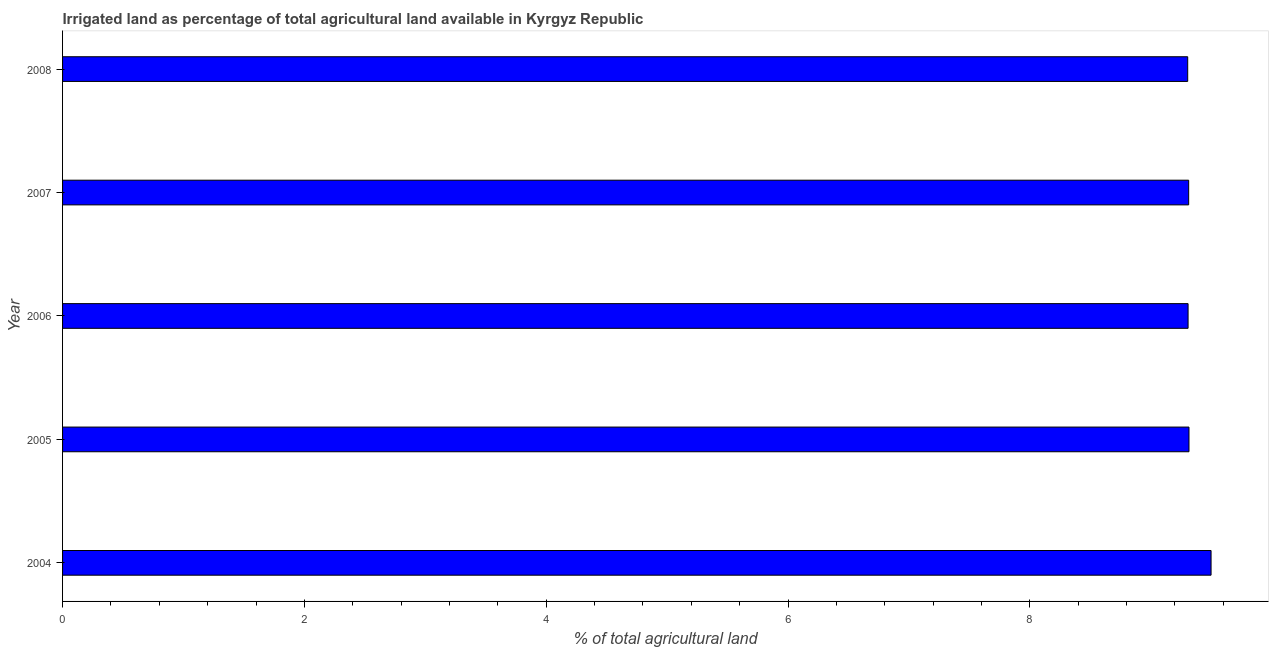Does the graph contain any zero values?
Your response must be concise. No. What is the title of the graph?
Ensure brevity in your answer.  Irrigated land as percentage of total agricultural land available in Kyrgyz Republic. What is the label or title of the X-axis?
Give a very brief answer. % of total agricultural land. What is the label or title of the Y-axis?
Offer a terse response. Year. What is the percentage of agricultural irrigated land in 2006?
Offer a terse response. 9.31. Across all years, what is the maximum percentage of agricultural irrigated land?
Offer a very short reply. 9.5. Across all years, what is the minimum percentage of agricultural irrigated land?
Provide a succinct answer. 9.31. In which year was the percentage of agricultural irrigated land maximum?
Your answer should be very brief. 2004. In which year was the percentage of agricultural irrigated land minimum?
Keep it short and to the point. 2008. What is the sum of the percentage of agricultural irrigated land?
Provide a short and direct response. 46.74. What is the difference between the percentage of agricultural irrigated land in 2005 and 2008?
Your answer should be very brief. 0.01. What is the average percentage of agricultural irrigated land per year?
Make the answer very short. 9.35. What is the median percentage of agricultural irrigated land?
Ensure brevity in your answer.  9.31. In how many years, is the percentage of agricultural irrigated land greater than 7.2 %?
Your answer should be compact. 5. Do a majority of the years between 2008 and 2006 (inclusive) have percentage of agricultural irrigated land greater than 4.8 %?
Your answer should be very brief. Yes. What is the ratio of the percentage of agricultural irrigated land in 2005 to that in 2007?
Make the answer very short. 1. Is the percentage of agricultural irrigated land in 2005 less than that in 2006?
Offer a very short reply. No. Is the difference between the percentage of agricultural irrigated land in 2005 and 2006 greater than the difference between any two years?
Your answer should be very brief. No. What is the difference between the highest and the second highest percentage of agricultural irrigated land?
Your answer should be very brief. 0.18. What is the difference between the highest and the lowest percentage of agricultural irrigated land?
Make the answer very short. 0.19. In how many years, is the percentage of agricultural irrigated land greater than the average percentage of agricultural irrigated land taken over all years?
Offer a very short reply. 1. Are all the bars in the graph horizontal?
Offer a terse response. Yes. What is the difference between two consecutive major ticks on the X-axis?
Keep it short and to the point. 2. Are the values on the major ticks of X-axis written in scientific E-notation?
Provide a short and direct response. No. What is the % of total agricultural land of 2004?
Your answer should be compact. 9.5. What is the % of total agricultural land of 2005?
Your answer should be compact. 9.32. What is the % of total agricultural land of 2006?
Give a very brief answer. 9.31. What is the % of total agricultural land of 2007?
Your answer should be compact. 9.31. What is the % of total agricultural land of 2008?
Your answer should be compact. 9.31. What is the difference between the % of total agricultural land in 2004 and 2005?
Provide a succinct answer. 0.18. What is the difference between the % of total agricultural land in 2004 and 2006?
Ensure brevity in your answer.  0.19. What is the difference between the % of total agricultural land in 2004 and 2007?
Provide a succinct answer. 0.19. What is the difference between the % of total agricultural land in 2004 and 2008?
Your response must be concise. 0.19. What is the difference between the % of total agricultural land in 2005 and 2006?
Your response must be concise. 0.01. What is the difference between the % of total agricultural land in 2005 and 2007?
Provide a succinct answer. 0. What is the difference between the % of total agricultural land in 2005 and 2008?
Keep it short and to the point. 0.01. What is the difference between the % of total agricultural land in 2006 and 2007?
Keep it short and to the point. -0. What is the difference between the % of total agricultural land in 2006 and 2008?
Provide a short and direct response. 0. What is the difference between the % of total agricultural land in 2007 and 2008?
Your response must be concise. 0.01. What is the ratio of the % of total agricultural land in 2004 to that in 2005?
Offer a terse response. 1.02. What is the ratio of the % of total agricultural land in 2004 to that in 2006?
Offer a very short reply. 1.02. What is the ratio of the % of total agricultural land in 2004 to that in 2007?
Provide a succinct answer. 1.02. What is the ratio of the % of total agricultural land in 2004 to that in 2008?
Your answer should be compact. 1.02. What is the ratio of the % of total agricultural land in 2006 to that in 2007?
Your answer should be compact. 1. What is the ratio of the % of total agricultural land in 2007 to that in 2008?
Keep it short and to the point. 1. 